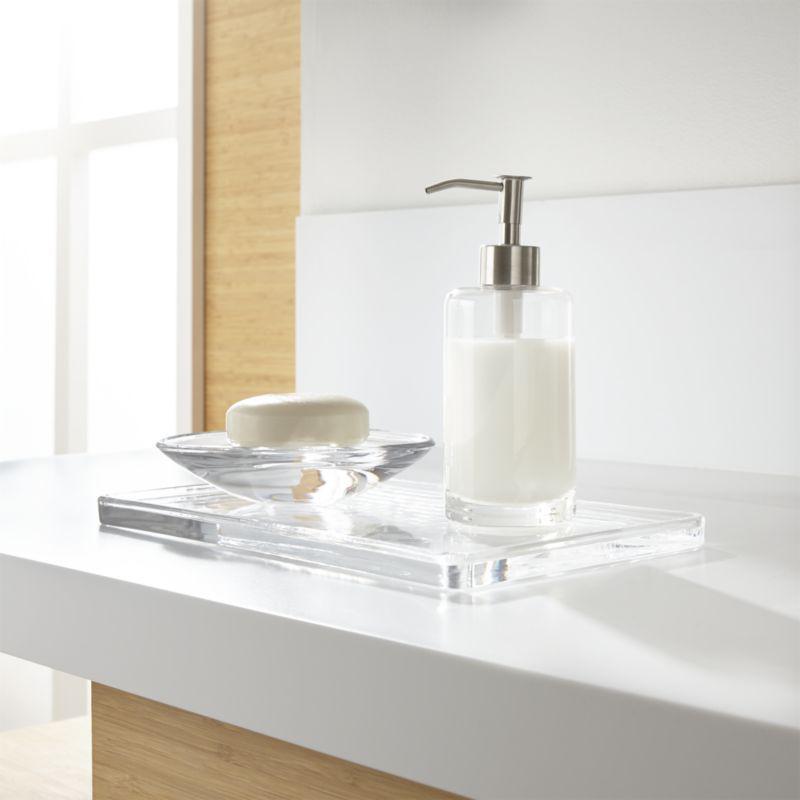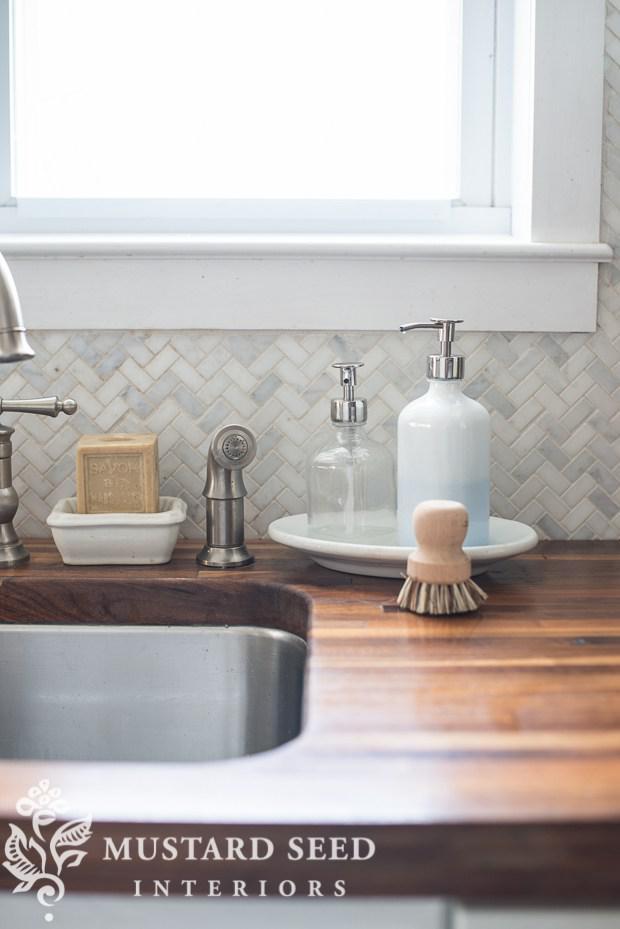The first image is the image on the left, the second image is the image on the right. Given the left and right images, does the statement "Multiple pump-top dispensers can be seen sitting on top of surfaces instead of mounted." hold true? Answer yes or no. Yes. The first image is the image on the left, the second image is the image on the right. Considering the images on both sides, is "At least one soap dispenser has a spout pointing towards the left." valid? Answer yes or no. Yes. 